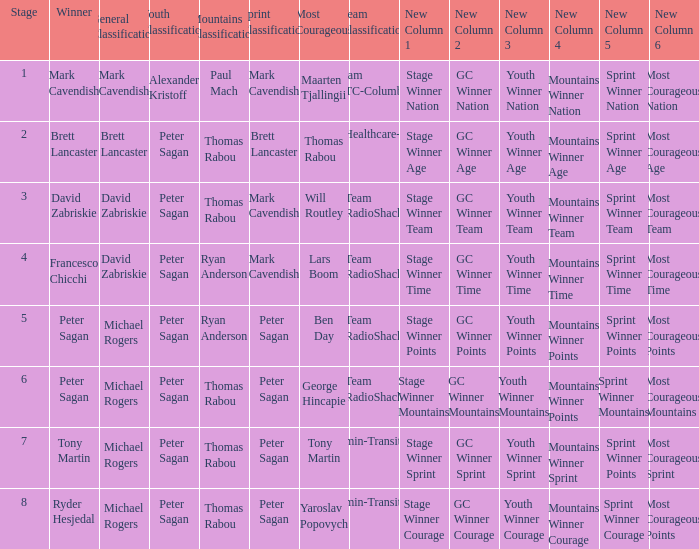When Mark Cavendish wins sprint classification and Maarten Tjallingii wins most courageous, who wins youth classification? Alexander Kristoff. 